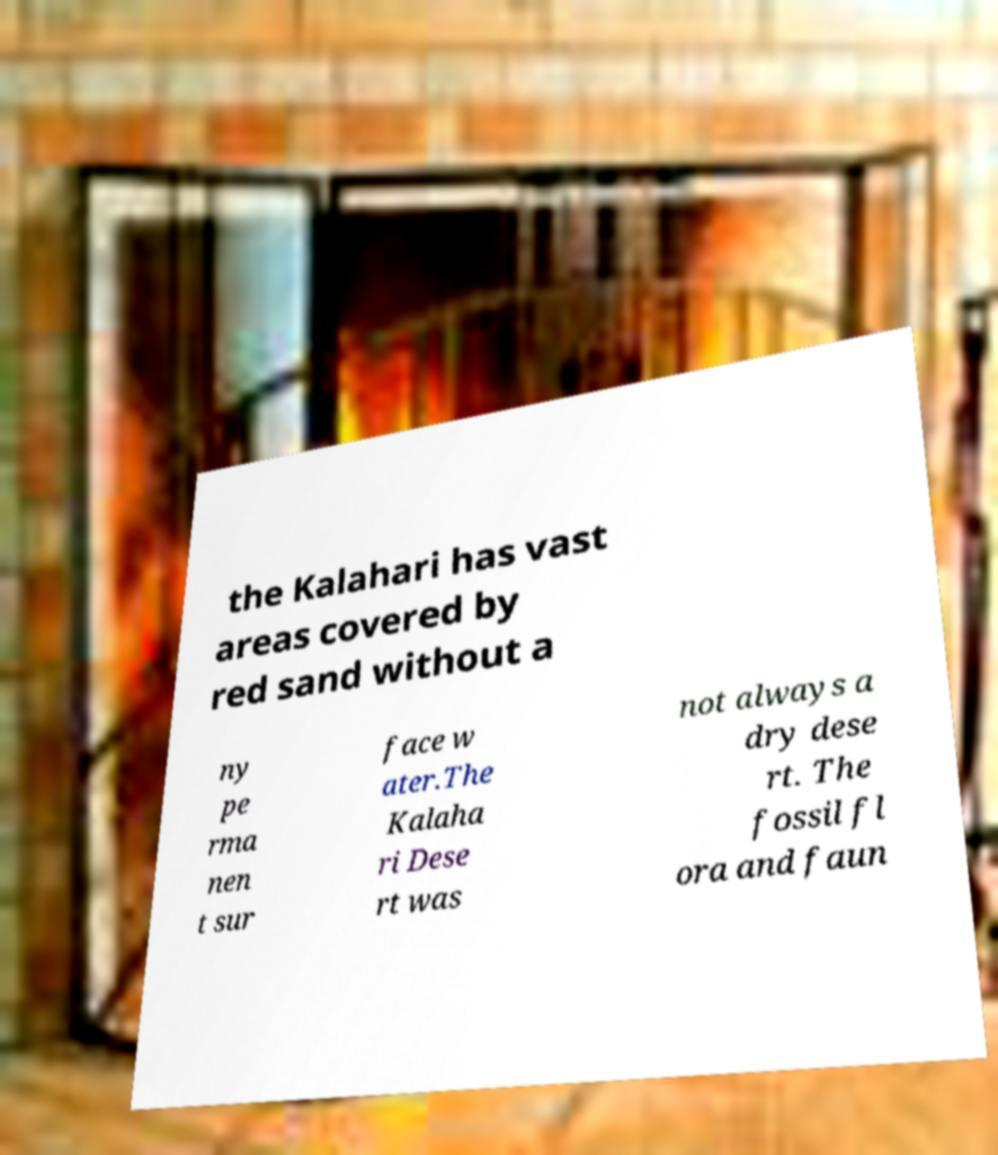Can you accurately transcribe the text from the provided image for me? the Kalahari has vast areas covered by red sand without a ny pe rma nen t sur face w ater.The Kalaha ri Dese rt was not always a dry dese rt. The fossil fl ora and faun 